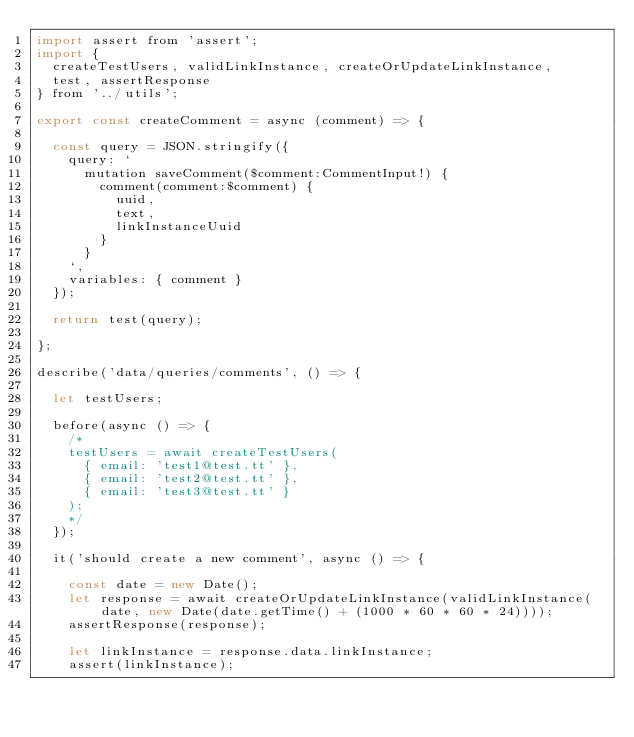<code> <loc_0><loc_0><loc_500><loc_500><_JavaScript_>import assert from 'assert';
import { 
  createTestUsers, validLinkInstance, createOrUpdateLinkInstance, 
  test, assertResponse 
} from '../utils';

export const createComment = async (comment) => {
  
  const query = JSON.stringify({
    query: `
      mutation saveComment($comment:CommentInput!) {
        comment(comment:$comment) {
          uuid,
          text,
          linkInstanceUuid
        }
      }
    `,
    variables: { comment }
  });
  
  return test(query);

};

describe('data/queries/comments', () => {

  let testUsers;

  before(async () => {
    /*
    testUsers = await createTestUsers(
      { email: 'test1@test.tt' },
      { email: 'test2@test.tt' },
      { email: 'test3@test.tt' }
    );
    */
  });

  it('should create a new comment', async () => {
    
    const date = new Date(); 
    let response = await createOrUpdateLinkInstance(validLinkInstance(date, new Date(date.getTime() + (1000 * 60 * 60 * 24)))); 
    assertResponse(response);
    
    let linkInstance = response.data.linkInstance;
    assert(linkInstance);
    </code> 